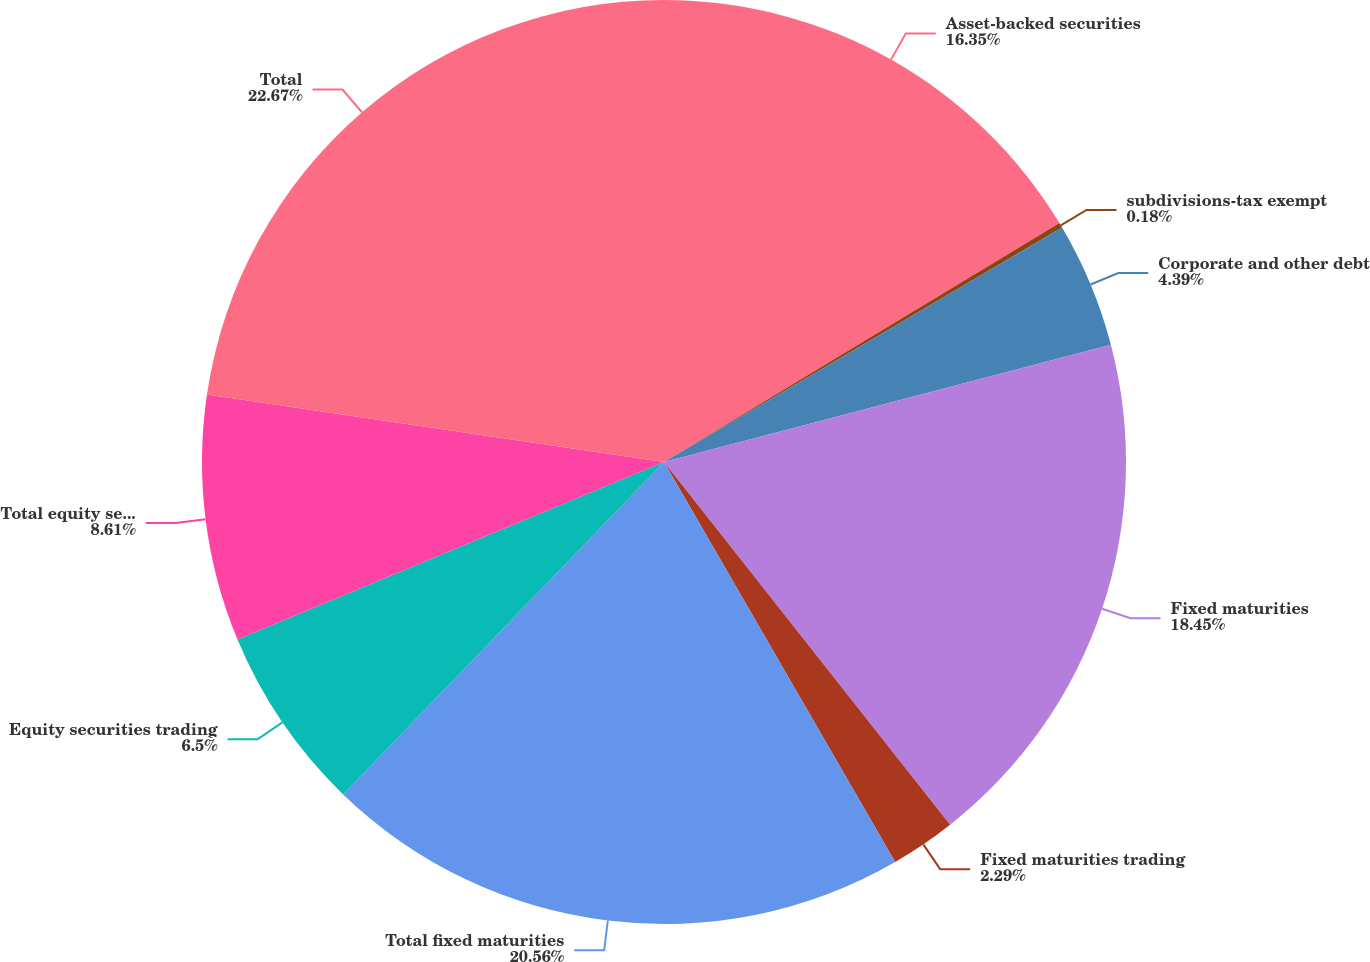Convert chart. <chart><loc_0><loc_0><loc_500><loc_500><pie_chart><fcel>Asset-backed securities<fcel>subdivisions-tax exempt<fcel>Corporate and other debt<fcel>Fixed maturities<fcel>Fixed maturities trading<fcel>Total fixed maturities<fcel>Equity securities trading<fcel>Total equity securities<fcel>Total<nl><fcel>16.35%<fcel>0.18%<fcel>4.39%<fcel>18.45%<fcel>2.29%<fcel>20.56%<fcel>6.5%<fcel>8.61%<fcel>22.67%<nl></chart> 